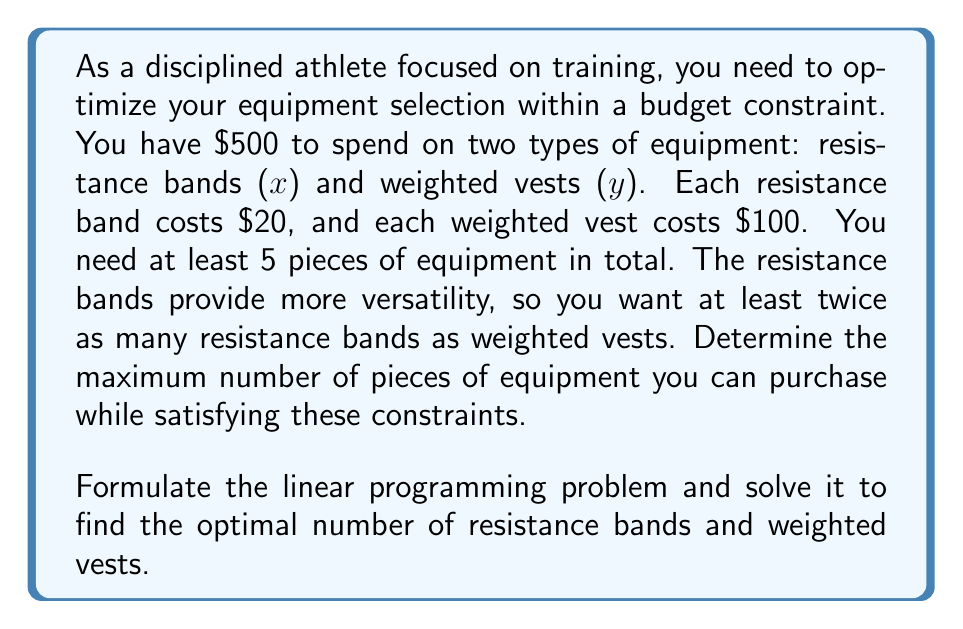Could you help me with this problem? Let's approach this step-by-step:

1) Define variables:
   $x$ = number of resistance bands
   $y$ = number of weighted vests

2) Formulate constraints:
   a) Budget constraint: $20x + 100y \leq 500$
   b) Total equipment constraint: $x + y \geq 5$
   c) Resistance bands vs weighted vests constraint: $x \geq 2y$
   d) Non-negativity constraints: $x \geq 0$, $y \geq 0$

3) Objective function:
   Maximize $z = x + y$

4) Solve graphically:
   Plot the constraints:
   
   [asy]
   import graph;
   size(200);
   xaxis("x", 0, 25, Arrow);
   yaxis("y", 0, 5, Arrow);
   draw((0,5)--(25,5), gray);
   draw((0,2.5)--(25,0), gray);
   draw((25,0)--(0,5), gray);
   draw((0,0)--(12.5,0)--(0,2.5)--cycle, rgb(0.7,0.7,1));
   label("Feasible Region", (4,1.5));
   dot((10,2.5));
   label("(10, 2.5)", (10,2.5), E);
   [/asy]

5) The optimal solution is at the intersection of $20x + 100y = 500$ and $x = 2y$:
   Solving these equations:
   $20(2y) + 100y = 500$
   $40y + 100y = 500$
   $140y = 500$
   $y = \frac{500}{140} = \frac{25}{7} \approx 3.57$

   Since $y$ must be an integer, we round down to $y = 3$
   Then $x = 2y = 2(3) = 6$

6) Check constraints:
   Budget: $20(6) + 100(3) = 120 + 300 = 420 \leq 500$
   Total equipment: $6 + 3 = 9 \geq 5$
   Resistance bands vs weighted vests: $6 \geq 2(3)$
   All constraints are satisfied.

Therefore, the optimal solution is 6 resistance bands and 3 weighted vests, for a total of 9 pieces of equipment.
Answer: The maximum number of pieces of equipment that can be purchased is 9, consisting of 6 resistance bands and 3 weighted vests. 